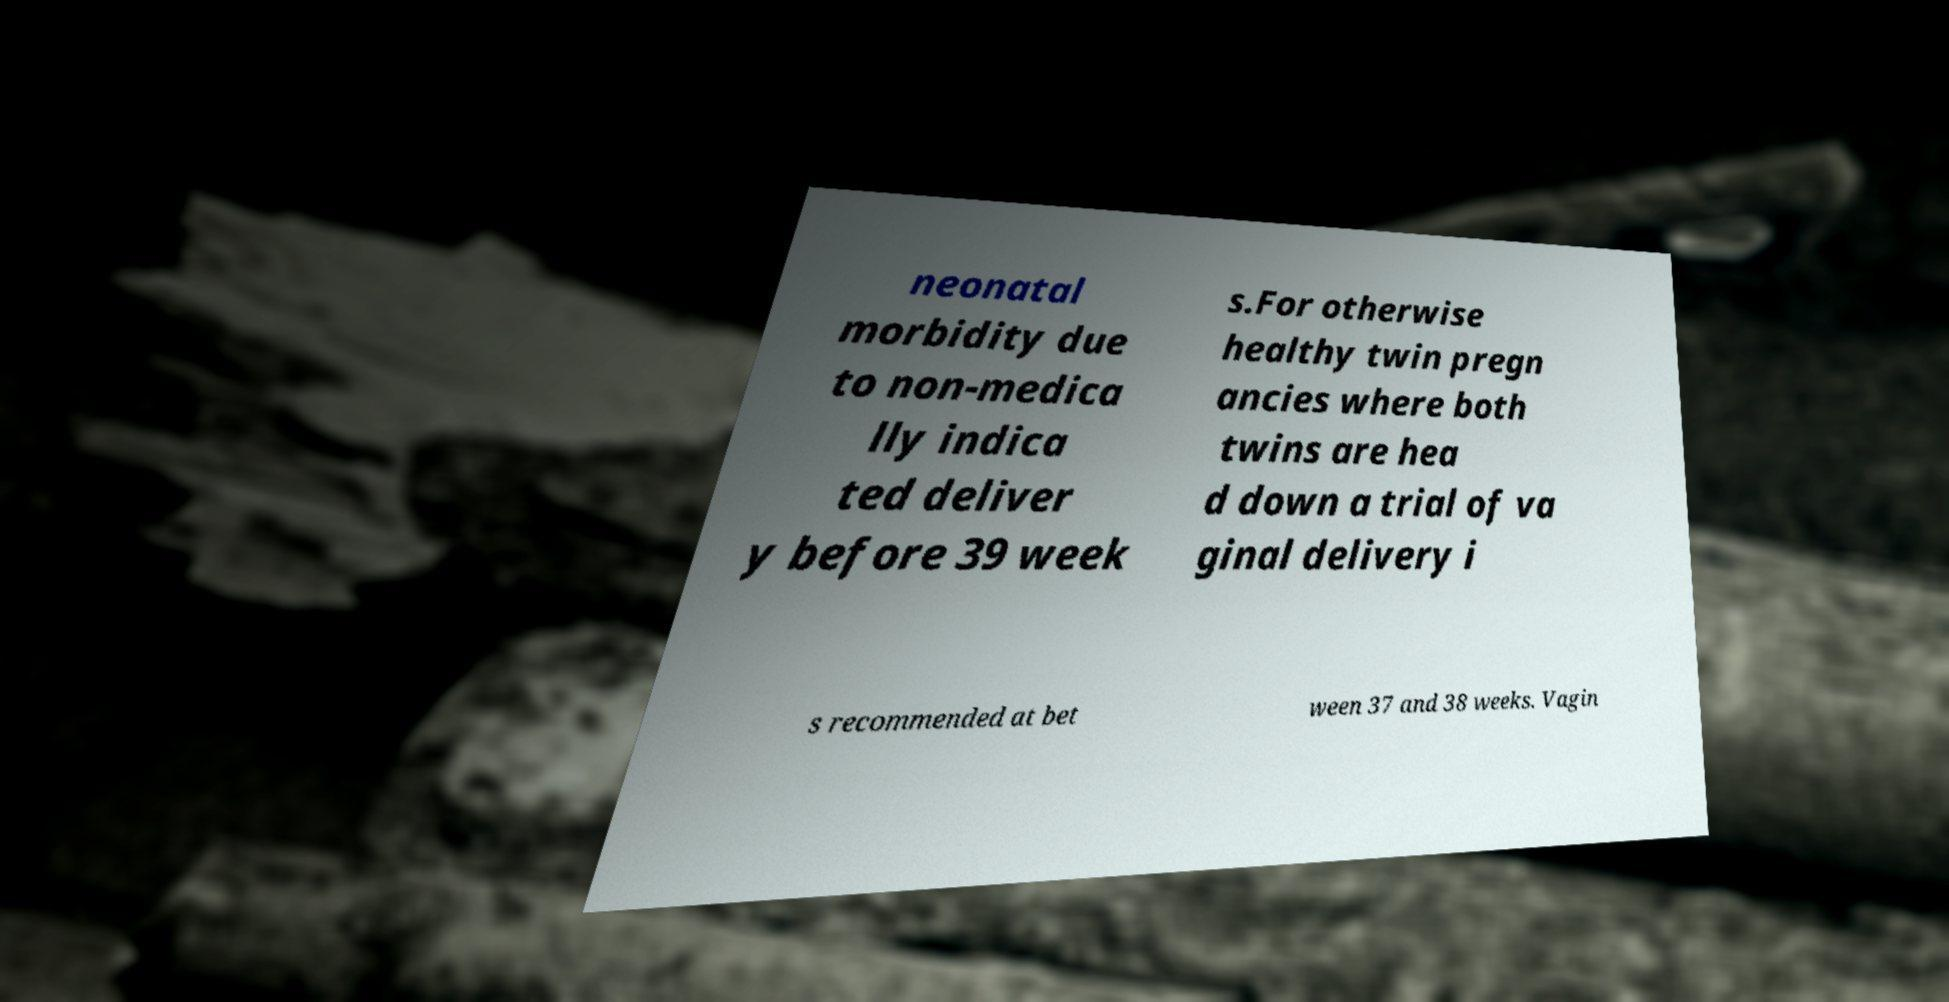Can you read and provide the text displayed in the image?This photo seems to have some interesting text. Can you extract and type it out for me? neonatal morbidity due to non-medica lly indica ted deliver y before 39 week s.For otherwise healthy twin pregn ancies where both twins are hea d down a trial of va ginal delivery i s recommended at bet ween 37 and 38 weeks. Vagin 